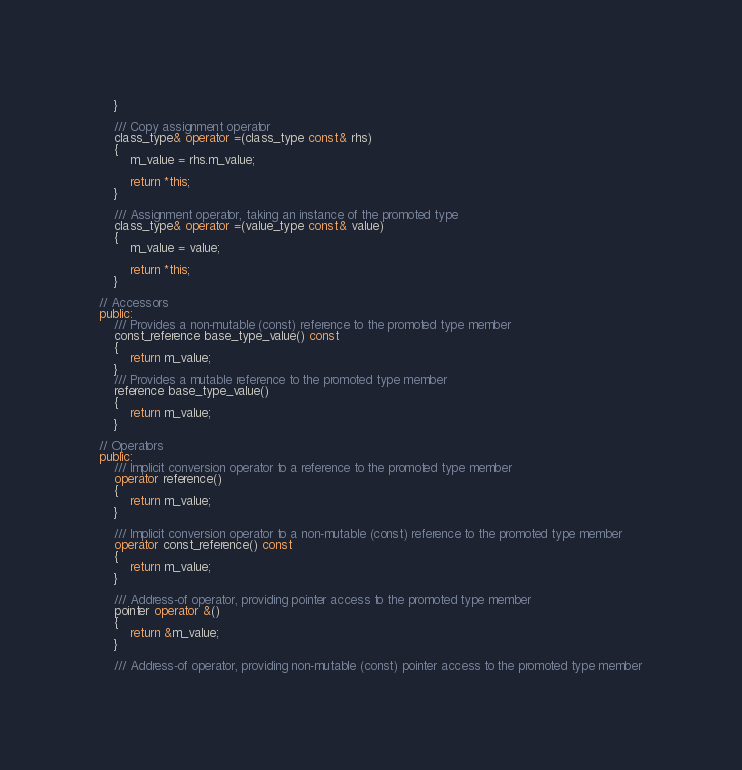Convert code to text. <code><loc_0><loc_0><loc_500><loc_500><_C++_>    }

    /// Copy assignment operator
    class_type& operator =(class_type const& rhs)
    {
        m_value = rhs.m_value;

        return *this;
    }

    /// Assignment operator, taking an instance of the promoted type
    class_type& operator =(value_type const& value)
    {
        m_value = value;

        return *this;
    }

// Accessors
public:
    /// Provides a non-mutable (const) reference to the promoted type member
    const_reference base_type_value() const
    {
        return m_value;
    }
    /// Provides a mutable reference to the promoted type member
    reference base_type_value()
    {
        return m_value;
    }

// Operators
public:
    /// Implicit conversion operator to a reference to the promoted type member
    operator reference()
    {
        return m_value;
    }

    /// Implicit conversion operator to a non-mutable (const) reference to the promoted type member
    operator const_reference() const
    {
        return m_value;
    }

    /// Address-of operator, providing pointer access to the promoted type member
    pointer operator &()
    {
        return &m_value;
    }

    /// Address-of operator, providing non-mutable (const) pointer access to the promoted type member</code> 